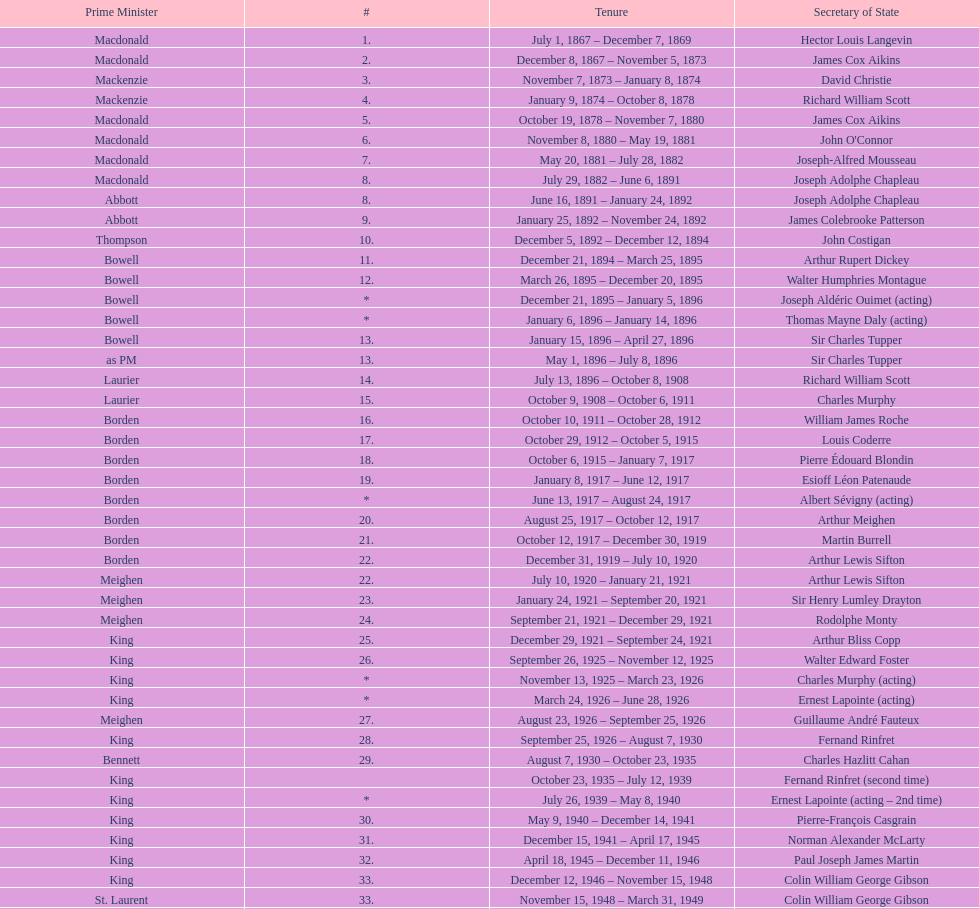What secretary of state served under both prime minister laurier and prime minister king? Charles Murphy. 